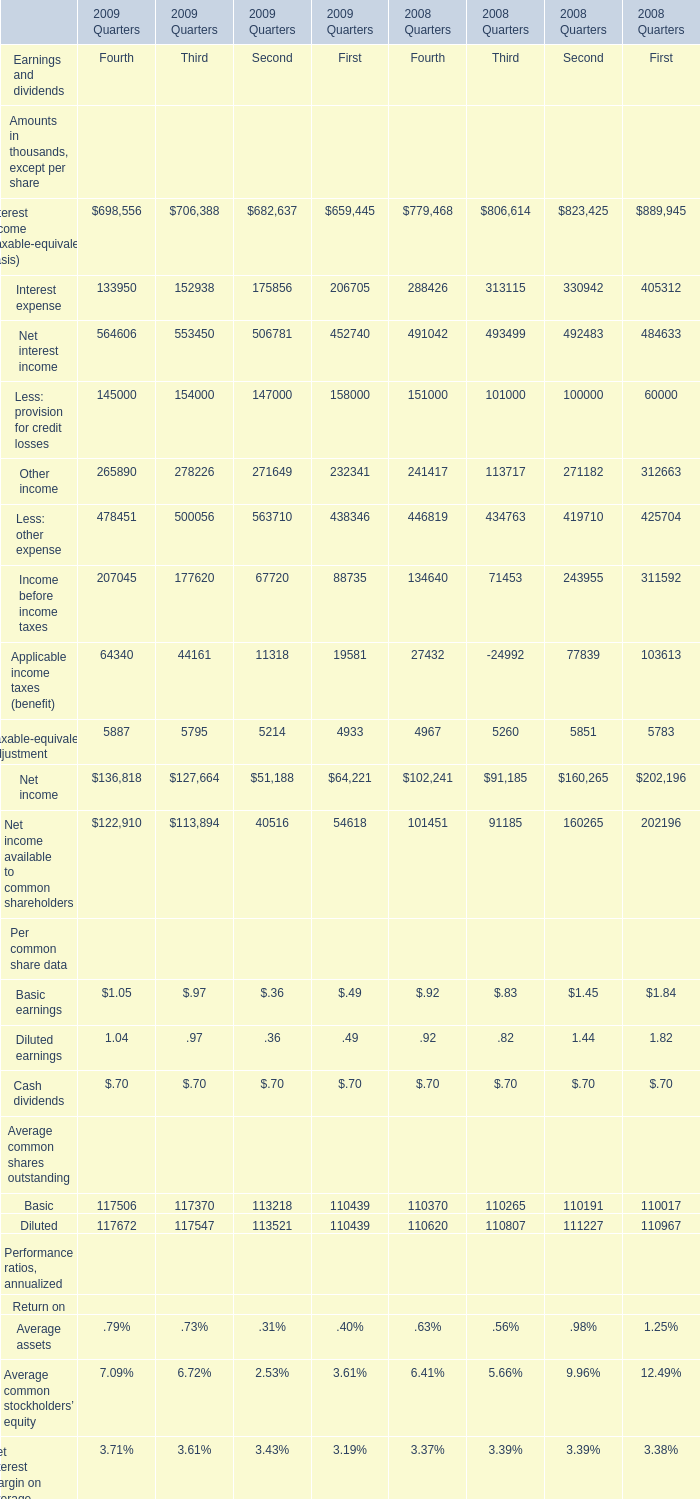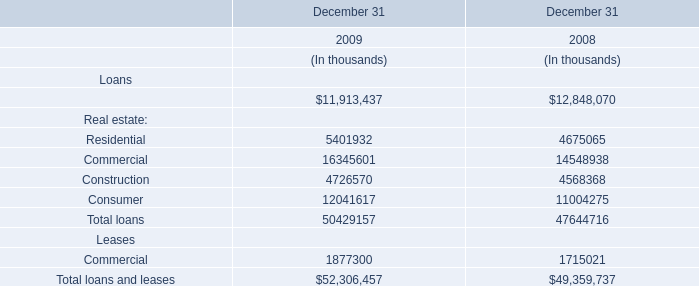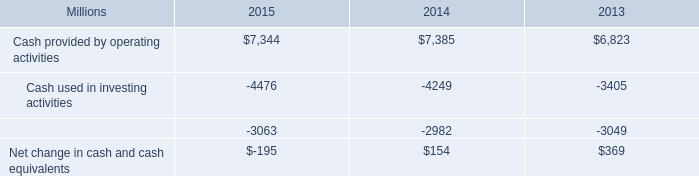Which year is Other income for First the lowest? 
Answer: 2009. 